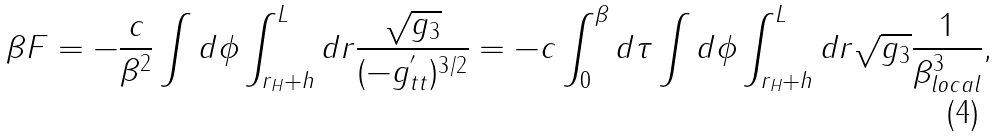<formula> <loc_0><loc_0><loc_500><loc_500>\beta F = - \frac { c } { \beta ^ { 2 } } \int d \phi \int _ { r _ { H } + h } ^ { L } d r \frac { \sqrt { g _ { 3 } } } { ( - g ^ { ^ { \prime } } _ { t t } ) ^ { 3 / 2 } } = - c \int _ { 0 } ^ { \beta } d \tau \int d \phi \int _ { r _ { H } + h } ^ { L } d r \sqrt { g _ { 3 } } \frac { 1 } { \beta _ { l o c a l } ^ { 3 } } ,</formula> 